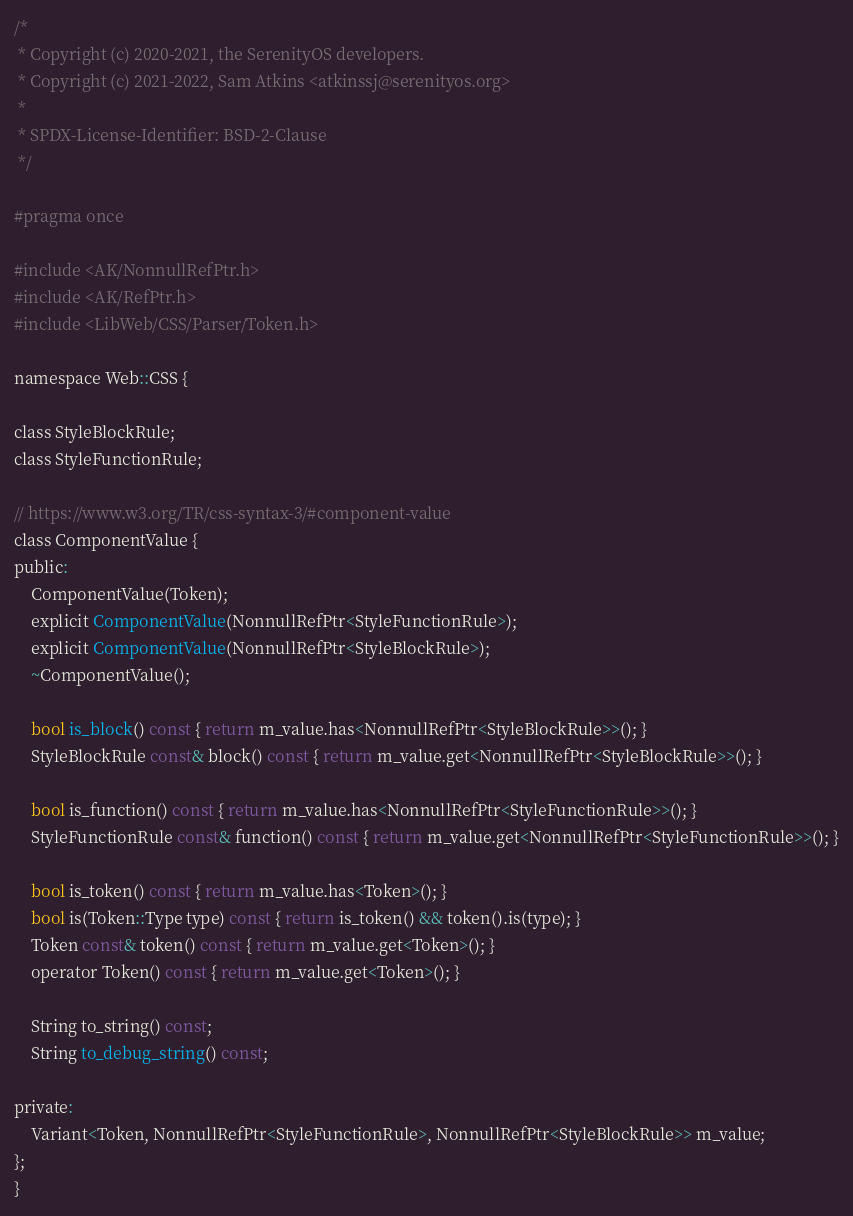Convert code to text. <code><loc_0><loc_0><loc_500><loc_500><_C_>/*
 * Copyright (c) 2020-2021, the SerenityOS developers.
 * Copyright (c) 2021-2022, Sam Atkins <atkinssj@serenityos.org>
 *
 * SPDX-License-Identifier: BSD-2-Clause
 */

#pragma once

#include <AK/NonnullRefPtr.h>
#include <AK/RefPtr.h>
#include <LibWeb/CSS/Parser/Token.h>

namespace Web::CSS {

class StyleBlockRule;
class StyleFunctionRule;

// https://www.w3.org/TR/css-syntax-3/#component-value
class ComponentValue {
public:
    ComponentValue(Token);
    explicit ComponentValue(NonnullRefPtr<StyleFunctionRule>);
    explicit ComponentValue(NonnullRefPtr<StyleBlockRule>);
    ~ComponentValue();

    bool is_block() const { return m_value.has<NonnullRefPtr<StyleBlockRule>>(); }
    StyleBlockRule const& block() const { return m_value.get<NonnullRefPtr<StyleBlockRule>>(); }

    bool is_function() const { return m_value.has<NonnullRefPtr<StyleFunctionRule>>(); }
    StyleFunctionRule const& function() const { return m_value.get<NonnullRefPtr<StyleFunctionRule>>(); }

    bool is_token() const { return m_value.has<Token>(); }
    bool is(Token::Type type) const { return is_token() && token().is(type); }
    Token const& token() const { return m_value.get<Token>(); }
    operator Token() const { return m_value.get<Token>(); }

    String to_string() const;
    String to_debug_string() const;

private:
    Variant<Token, NonnullRefPtr<StyleFunctionRule>, NonnullRefPtr<StyleBlockRule>> m_value;
};
}
</code> 